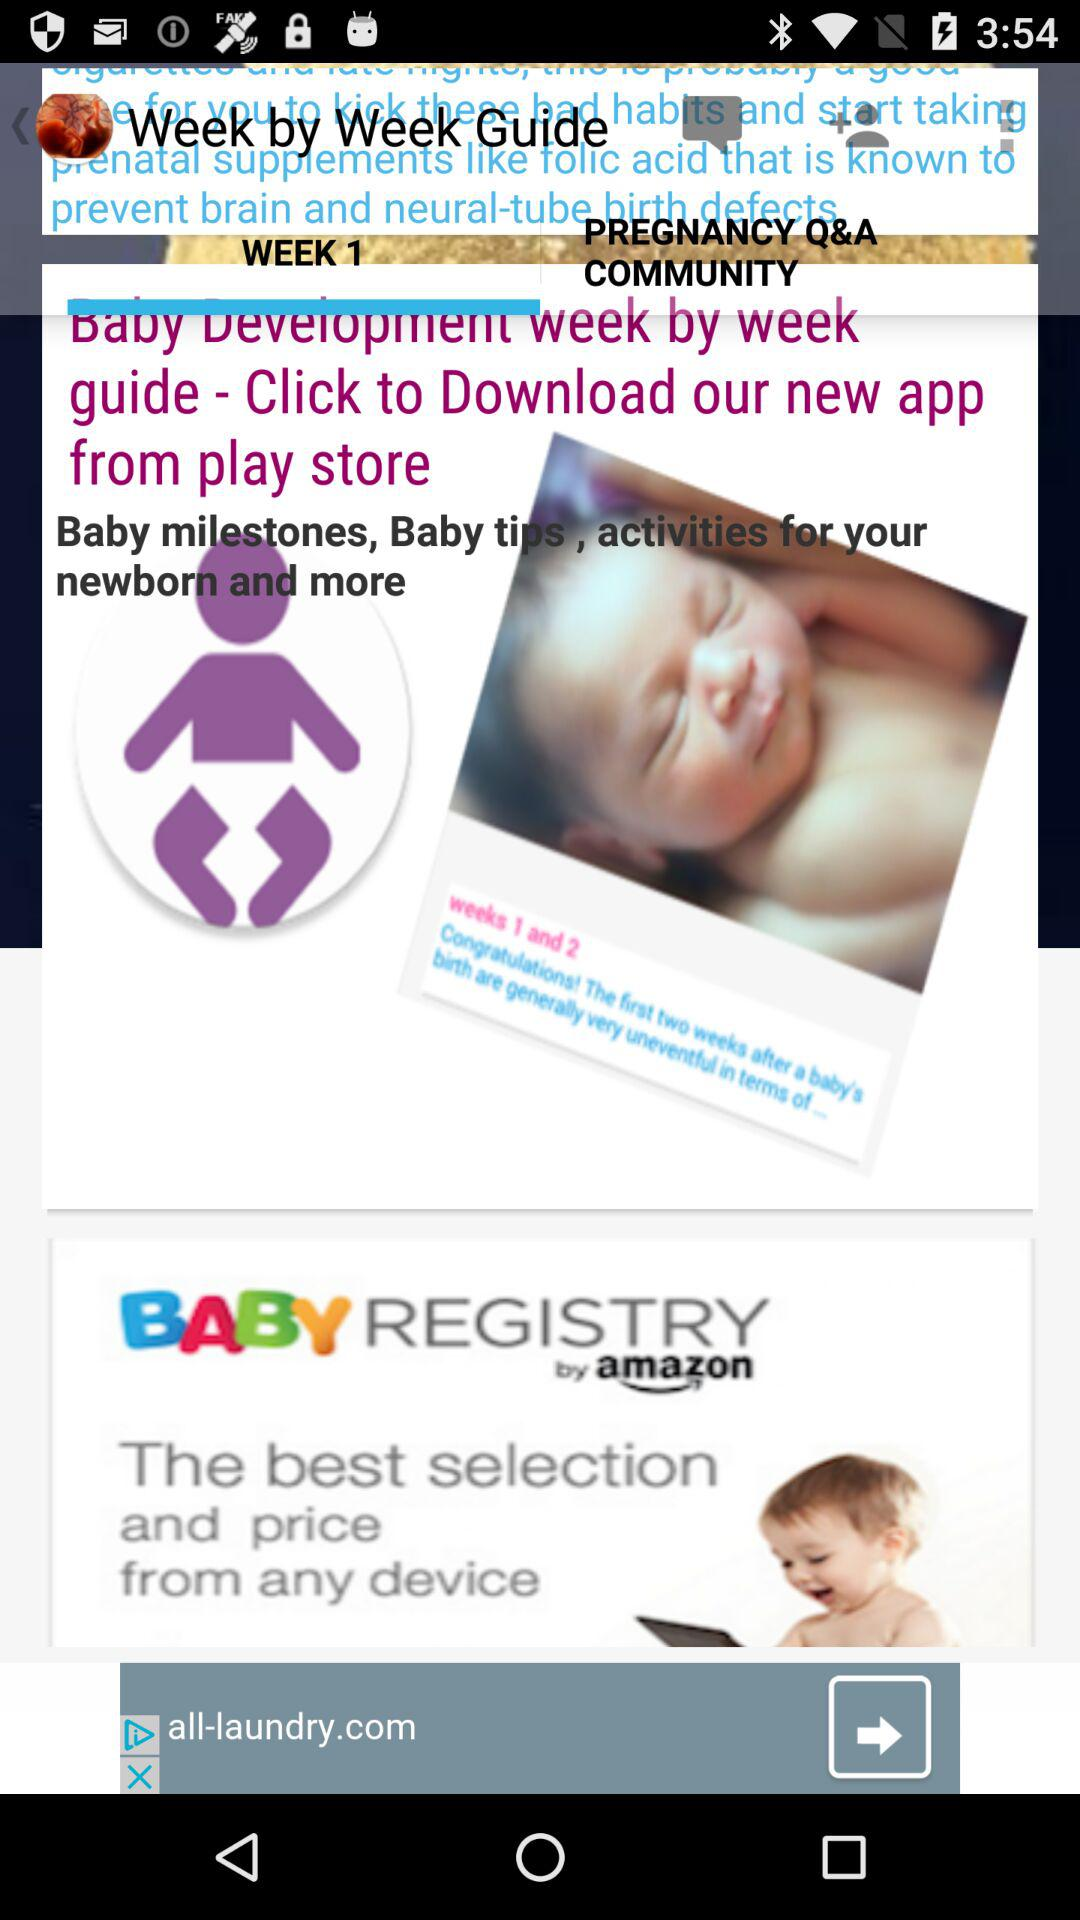What is the name of the application? The application name is "Week by Week Guide". 